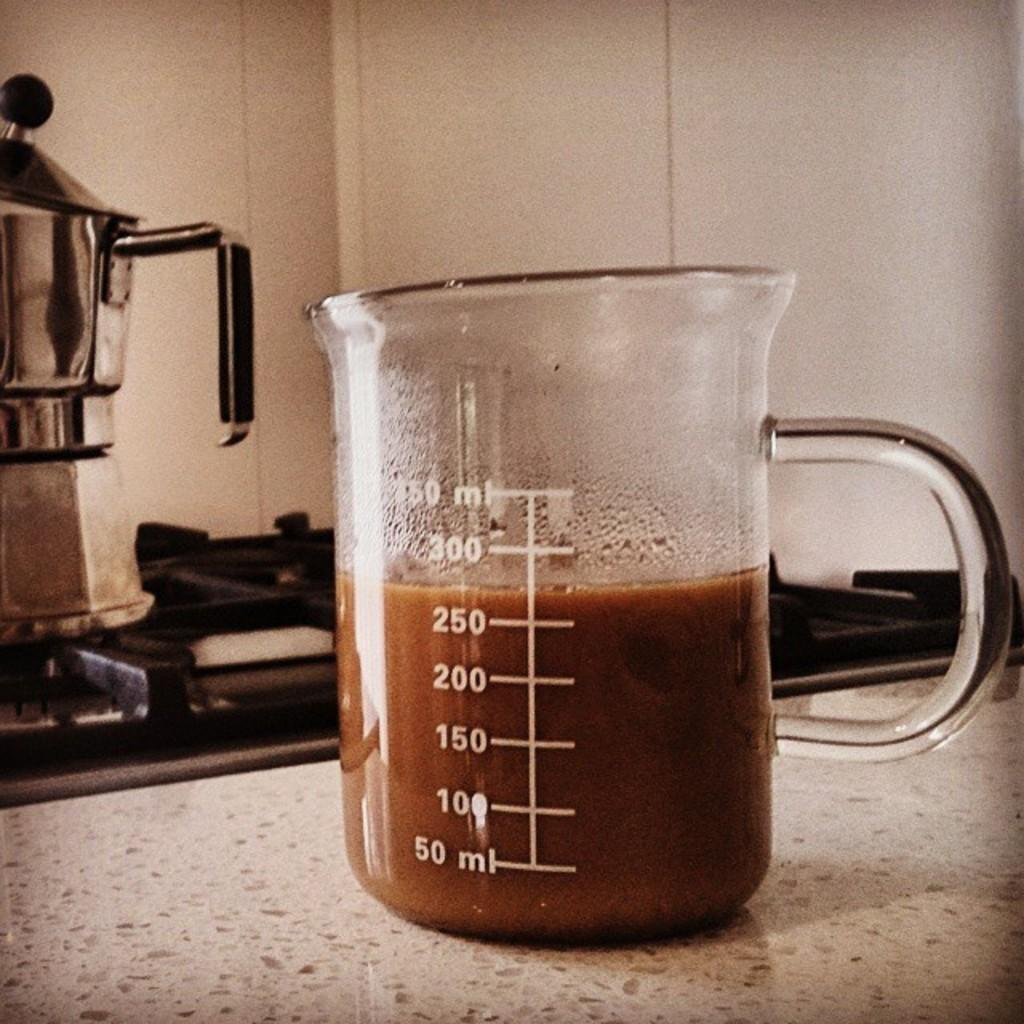<image>
Summarize the visual content of the image. Measuring cup that measures up to 350 ml. 